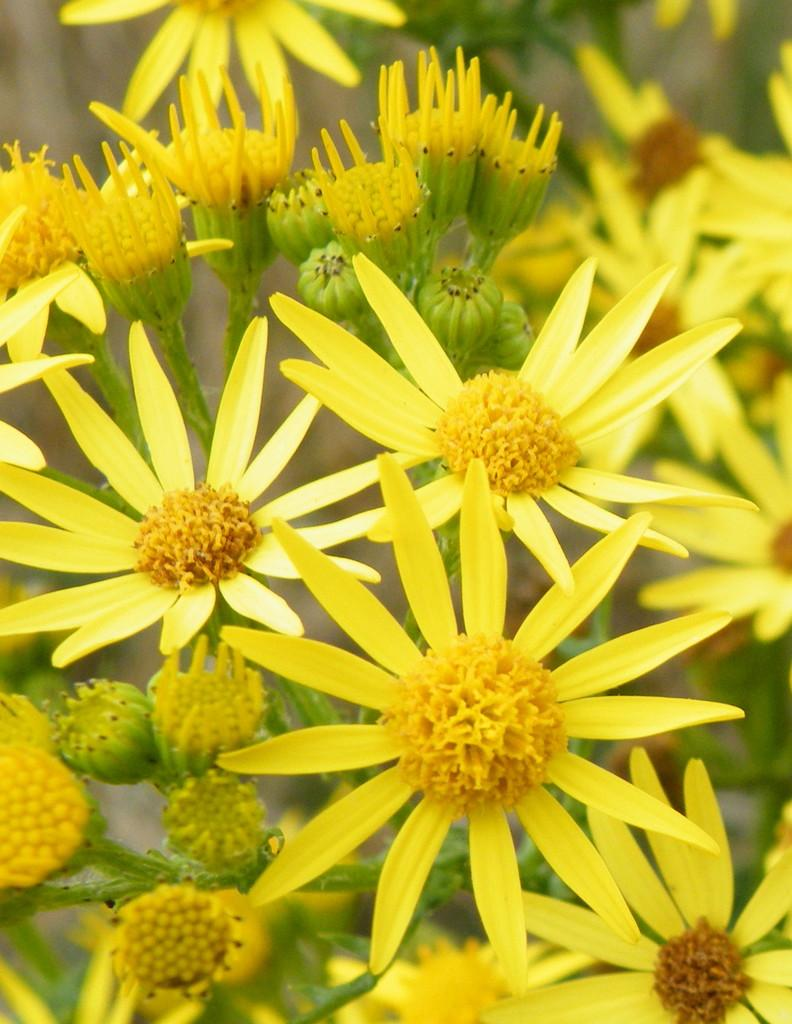What type of living organisms can be seen in the image? There are flowers in the image. Can you tell me how many chickens are present in the image? There are no chickens present in the image; it only features flowers. What type of animal can be seen interacting with the flowers in the image? There is no animal interacting with the flowers in the image. 